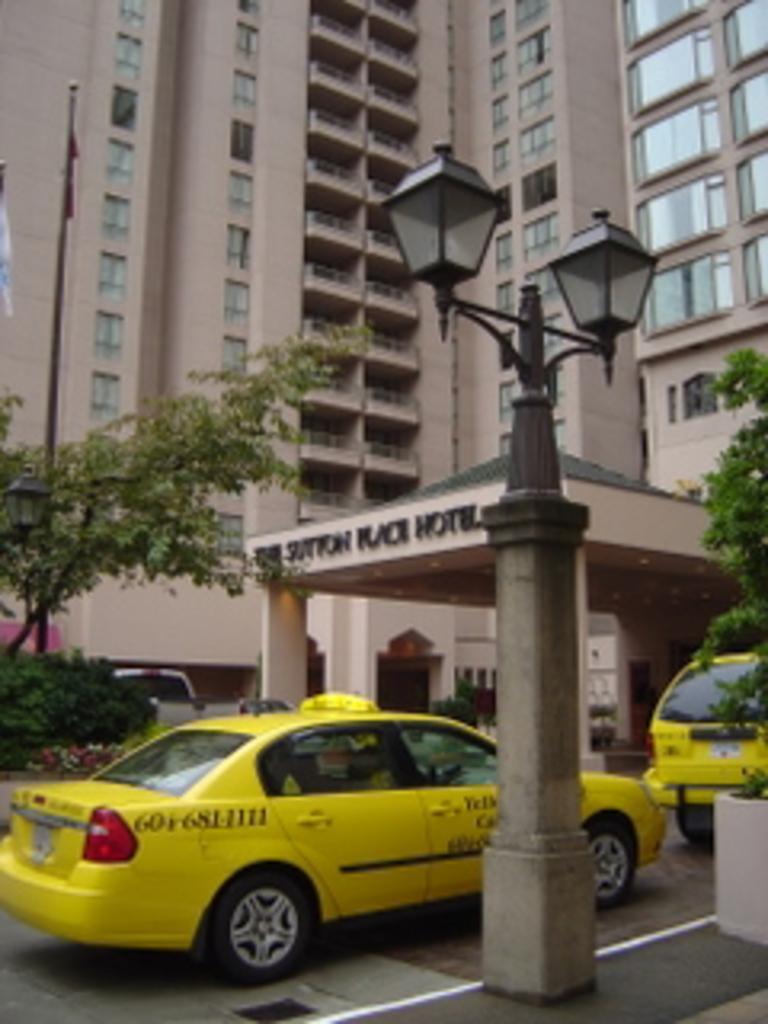Can you describe this image briefly? In this picture, there are vehicles on the road which are in yellow in color. Beside it, there is a pole with lights. On the top, there is a building. Towards the left and right, there are trees. 